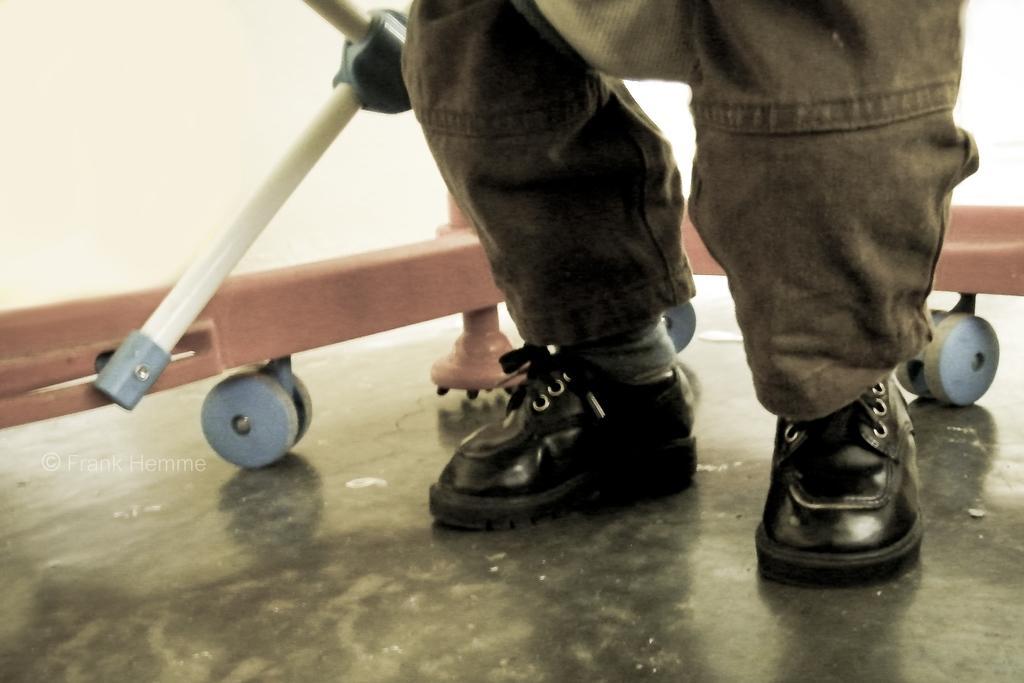Can you describe this image briefly? In the image there are legs of a person with shoes. Behind the legs there are rods with wheels. And there is a white background. 